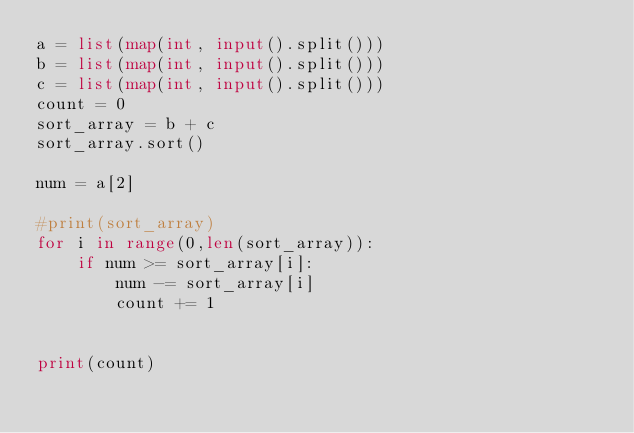<code> <loc_0><loc_0><loc_500><loc_500><_Python_>a = list(map(int, input().split()))
b = list(map(int, input().split()))
c = list(map(int, input().split()))
count = 0
sort_array = b + c
sort_array.sort()

num = a[2]

#print(sort_array)
for i in range(0,len(sort_array)):
    if num >= sort_array[i]:
        num -= sort_array[i]
        count += 1


print(count)</code> 